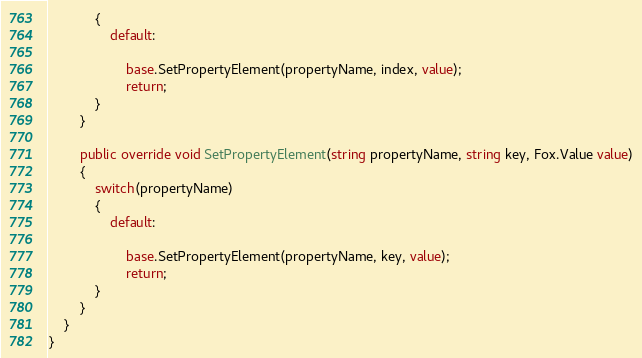<code> <loc_0><loc_0><loc_500><loc_500><_C#_>            {
                default:
					
                    base.SetPropertyElement(propertyName, index, value);
                    return;
            }
        }
        
        public override void SetPropertyElement(string propertyName, string key, Fox.Value value)
        {
            switch(propertyName)
            {
                default:
					
                    base.SetPropertyElement(propertyName, key, value);
                    return;
            }
        }
    }
}</code> 